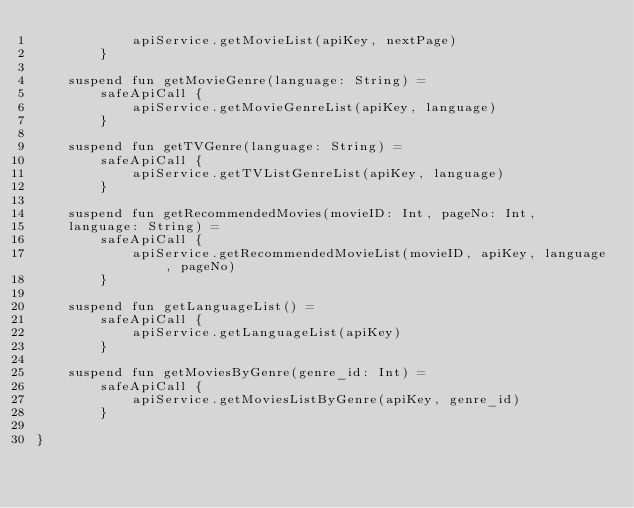<code> <loc_0><loc_0><loc_500><loc_500><_Kotlin_>            apiService.getMovieList(apiKey, nextPage)
        }

    suspend fun getMovieGenre(language: String) =
        safeApiCall {
            apiService.getMovieGenreList(apiKey, language)
        }

    suspend fun getTVGenre(language: String) =
        safeApiCall {
            apiService.getTVListGenreList(apiKey, language)
        }

    suspend fun getRecommendedMovies(movieID: Int, pageNo: Int,
    language: String) =
        safeApiCall {
            apiService.getRecommendedMovieList(movieID, apiKey, language, pageNo)
        }

    suspend fun getLanguageList() =
        safeApiCall {
            apiService.getLanguageList(apiKey)
        }

    suspend fun getMoviesByGenre(genre_id: Int) =
        safeApiCall {
            apiService.getMoviesListByGenre(apiKey, genre_id)
        }

}</code> 